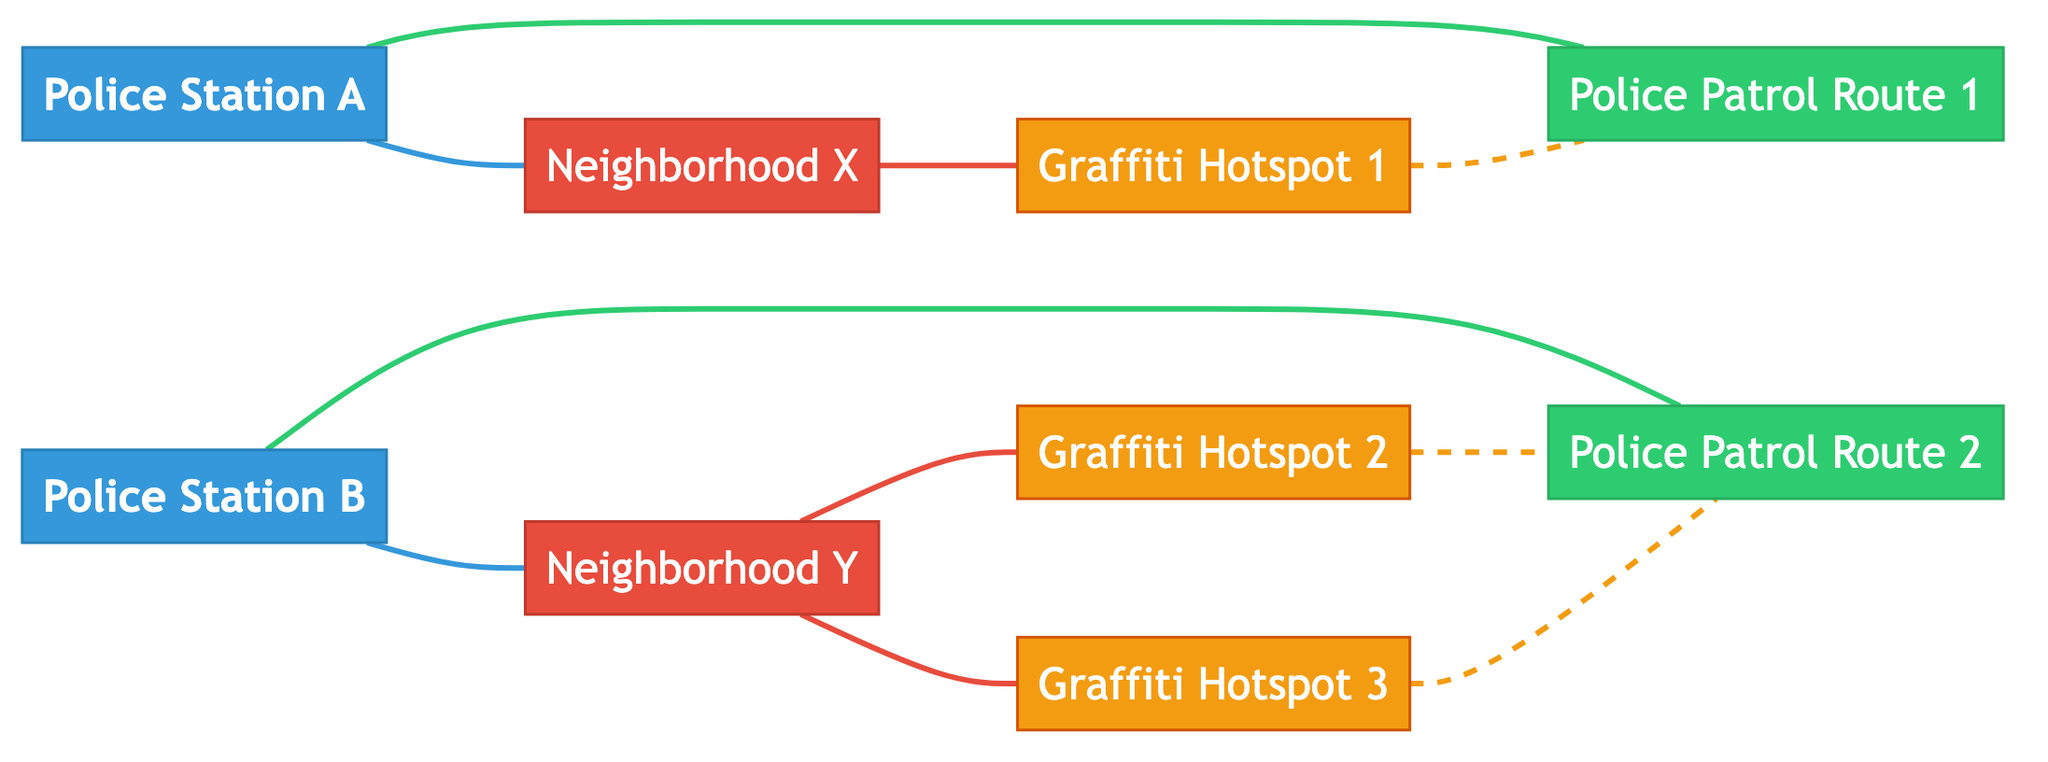What is the total number of nodes in the diagram? The diagram includes nodes for police stations, neighborhoods, graffiti hotspots, and police patrol routes. Counting all the unique nodes listed (1 to 9), we have a total of 9 nodes.
Answer: 9 Which two police stations are connected to their respective neighborhoods? Police Station A is connected to Neighborhood X, and Police Station B is connected to Neighborhood Y as indicated by the edges between them.
Answer: Police Station A and Police Station B How many graffiti hotspots are connected to Police Patrol Route 2? There are two edges coming from the graffiti hotspots (Graffiti Hotspot 2 and Graffiti Hotspot 3) that end at Police Patrol Route 2.
Answer: 2 Which neighborhood has the highest number of graffiti hotspots connected to it? Neighborhood Y is connected to two graffiti hotspots (Graffiti Hotspot 2 and Graffiti Hotspot 3), while Neighborhood X is only connected to one. Thus, Neighborhood Y has the highest number.
Answer: Neighborhood Y What type of edges connect Graffiti Hotspot 1 and Police Patrol Route 1? The edges between Graffiti Hotspot 1 and Police Patrol Route 1 indicate "route coverage" showing that this hotspot is monitored by this patrol route.
Answer: route coverage 